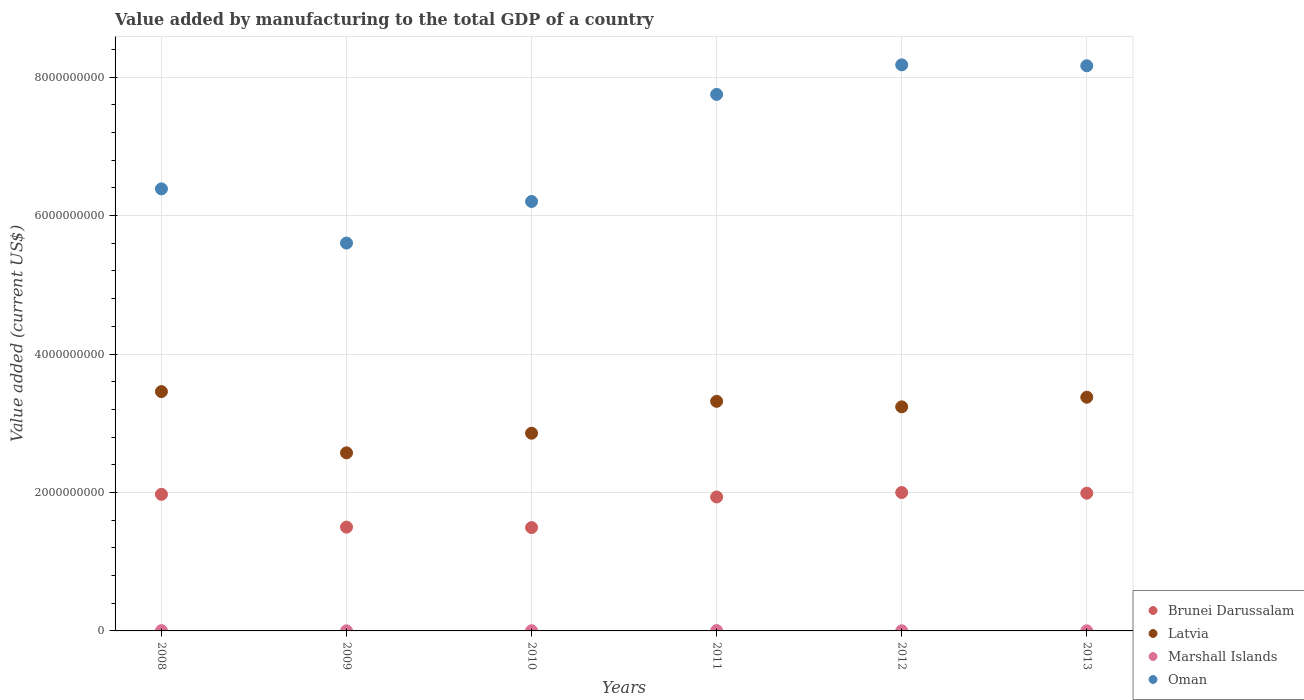How many different coloured dotlines are there?
Provide a short and direct response. 4. Is the number of dotlines equal to the number of legend labels?
Offer a terse response. Yes. What is the value added by manufacturing to the total GDP in Brunei Darussalam in 2011?
Give a very brief answer. 1.93e+09. Across all years, what is the maximum value added by manufacturing to the total GDP in Oman?
Offer a very short reply. 8.18e+09. Across all years, what is the minimum value added by manufacturing to the total GDP in Brunei Darussalam?
Offer a terse response. 1.49e+09. In which year was the value added by manufacturing to the total GDP in Brunei Darussalam maximum?
Make the answer very short. 2012. What is the total value added by manufacturing to the total GDP in Oman in the graph?
Offer a very short reply. 4.23e+1. What is the difference between the value added by manufacturing to the total GDP in Oman in 2011 and that in 2012?
Offer a very short reply. -4.27e+08. What is the difference between the value added by manufacturing to the total GDP in Marshall Islands in 2013 and the value added by manufacturing to the total GDP in Oman in 2012?
Your answer should be very brief. -8.18e+09. What is the average value added by manufacturing to the total GDP in Latvia per year?
Give a very brief answer. 3.14e+09. In the year 2012, what is the difference between the value added by manufacturing to the total GDP in Oman and value added by manufacturing to the total GDP in Brunei Darussalam?
Offer a very short reply. 6.18e+09. What is the ratio of the value added by manufacturing to the total GDP in Brunei Darussalam in 2010 to that in 2013?
Give a very brief answer. 0.75. Is the value added by manufacturing to the total GDP in Oman in 2008 less than that in 2009?
Make the answer very short. No. Is the difference between the value added by manufacturing to the total GDP in Oman in 2008 and 2013 greater than the difference between the value added by manufacturing to the total GDP in Brunei Darussalam in 2008 and 2013?
Provide a short and direct response. No. What is the difference between the highest and the second highest value added by manufacturing to the total GDP in Oman?
Offer a very short reply. 1.30e+07. What is the difference between the highest and the lowest value added by manufacturing to the total GDP in Brunei Darussalam?
Your response must be concise. 5.06e+08. Is it the case that in every year, the sum of the value added by manufacturing to the total GDP in Brunei Darussalam and value added by manufacturing to the total GDP in Marshall Islands  is greater than the value added by manufacturing to the total GDP in Oman?
Provide a short and direct response. No. Is the value added by manufacturing to the total GDP in Oman strictly greater than the value added by manufacturing to the total GDP in Latvia over the years?
Your response must be concise. Yes. Is the value added by manufacturing to the total GDP in Brunei Darussalam strictly less than the value added by manufacturing to the total GDP in Marshall Islands over the years?
Your response must be concise. No. How many years are there in the graph?
Give a very brief answer. 6. What is the difference between two consecutive major ticks on the Y-axis?
Your response must be concise. 2.00e+09. How many legend labels are there?
Provide a succinct answer. 4. What is the title of the graph?
Provide a short and direct response. Value added by manufacturing to the total GDP of a country. Does "Zimbabwe" appear as one of the legend labels in the graph?
Your answer should be compact. No. What is the label or title of the Y-axis?
Provide a succinct answer. Value added (current US$). What is the Value added (current US$) of Brunei Darussalam in 2008?
Ensure brevity in your answer.  1.97e+09. What is the Value added (current US$) in Latvia in 2008?
Offer a terse response. 3.46e+09. What is the Value added (current US$) in Marshall Islands in 2008?
Offer a terse response. 4.20e+06. What is the Value added (current US$) of Oman in 2008?
Your answer should be very brief. 6.39e+09. What is the Value added (current US$) of Brunei Darussalam in 2009?
Ensure brevity in your answer.  1.50e+09. What is the Value added (current US$) of Latvia in 2009?
Provide a succinct answer. 2.57e+09. What is the Value added (current US$) in Marshall Islands in 2009?
Offer a very short reply. 1.06e+06. What is the Value added (current US$) of Oman in 2009?
Give a very brief answer. 5.60e+09. What is the Value added (current US$) in Brunei Darussalam in 2010?
Offer a terse response. 1.49e+09. What is the Value added (current US$) in Latvia in 2010?
Make the answer very short. 2.86e+09. What is the Value added (current US$) of Marshall Islands in 2010?
Your answer should be very brief. 2.80e+06. What is the Value added (current US$) in Oman in 2010?
Your answer should be very brief. 6.20e+09. What is the Value added (current US$) of Brunei Darussalam in 2011?
Provide a succinct answer. 1.93e+09. What is the Value added (current US$) of Latvia in 2011?
Keep it short and to the point. 3.32e+09. What is the Value added (current US$) in Marshall Islands in 2011?
Your response must be concise. 4.95e+06. What is the Value added (current US$) of Oman in 2011?
Ensure brevity in your answer.  7.75e+09. What is the Value added (current US$) of Brunei Darussalam in 2012?
Make the answer very short. 2.00e+09. What is the Value added (current US$) in Latvia in 2012?
Provide a short and direct response. 3.24e+09. What is the Value added (current US$) of Marshall Islands in 2012?
Your answer should be very brief. 1.80e+06. What is the Value added (current US$) in Oman in 2012?
Ensure brevity in your answer.  8.18e+09. What is the Value added (current US$) of Brunei Darussalam in 2013?
Provide a short and direct response. 1.99e+09. What is the Value added (current US$) of Latvia in 2013?
Ensure brevity in your answer.  3.38e+09. What is the Value added (current US$) in Marshall Islands in 2013?
Your answer should be very brief. 1.32e+06. What is the Value added (current US$) in Oman in 2013?
Offer a very short reply. 8.16e+09. Across all years, what is the maximum Value added (current US$) in Brunei Darussalam?
Provide a succinct answer. 2.00e+09. Across all years, what is the maximum Value added (current US$) in Latvia?
Give a very brief answer. 3.46e+09. Across all years, what is the maximum Value added (current US$) of Marshall Islands?
Your response must be concise. 4.95e+06. Across all years, what is the maximum Value added (current US$) of Oman?
Your answer should be very brief. 8.18e+09. Across all years, what is the minimum Value added (current US$) in Brunei Darussalam?
Keep it short and to the point. 1.49e+09. Across all years, what is the minimum Value added (current US$) of Latvia?
Offer a very short reply. 2.57e+09. Across all years, what is the minimum Value added (current US$) of Marshall Islands?
Ensure brevity in your answer.  1.06e+06. Across all years, what is the minimum Value added (current US$) in Oman?
Keep it short and to the point. 5.60e+09. What is the total Value added (current US$) in Brunei Darussalam in the graph?
Provide a short and direct response. 1.09e+1. What is the total Value added (current US$) of Latvia in the graph?
Ensure brevity in your answer.  1.88e+1. What is the total Value added (current US$) in Marshall Islands in the graph?
Your answer should be very brief. 1.61e+07. What is the total Value added (current US$) in Oman in the graph?
Keep it short and to the point. 4.23e+1. What is the difference between the Value added (current US$) in Brunei Darussalam in 2008 and that in 2009?
Keep it short and to the point. 4.74e+08. What is the difference between the Value added (current US$) of Latvia in 2008 and that in 2009?
Ensure brevity in your answer.  8.85e+08. What is the difference between the Value added (current US$) in Marshall Islands in 2008 and that in 2009?
Give a very brief answer. 3.13e+06. What is the difference between the Value added (current US$) of Oman in 2008 and that in 2009?
Your response must be concise. 7.83e+08. What is the difference between the Value added (current US$) of Brunei Darussalam in 2008 and that in 2010?
Ensure brevity in your answer.  4.80e+08. What is the difference between the Value added (current US$) in Latvia in 2008 and that in 2010?
Offer a terse response. 6.01e+08. What is the difference between the Value added (current US$) in Marshall Islands in 2008 and that in 2010?
Keep it short and to the point. 1.40e+06. What is the difference between the Value added (current US$) of Oman in 2008 and that in 2010?
Keep it short and to the point. 1.82e+08. What is the difference between the Value added (current US$) of Brunei Darussalam in 2008 and that in 2011?
Give a very brief answer. 3.81e+07. What is the difference between the Value added (current US$) of Latvia in 2008 and that in 2011?
Your answer should be very brief. 1.41e+08. What is the difference between the Value added (current US$) of Marshall Islands in 2008 and that in 2011?
Provide a short and direct response. -7.55e+05. What is the difference between the Value added (current US$) of Oman in 2008 and that in 2011?
Your answer should be very brief. -1.36e+09. What is the difference between the Value added (current US$) in Brunei Darussalam in 2008 and that in 2012?
Your response must be concise. -2.64e+07. What is the difference between the Value added (current US$) of Latvia in 2008 and that in 2012?
Your response must be concise. 2.20e+08. What is the difference between the Value added (current US$) of Marshall Islands in 2008 and that in 2012?
Your answer should be very brief. 2.40e+06. What is the difference between the Value added (current US$) of Oman in 2008 and that in 2012?
Your answer should be compact. -1.79e+09. What is the difference between the Value added (current US$) in Brunei Darussalam in 2008 and that in 2013?
Offer a terse response. -1.66e+07. What is the difference between the Value added (current US$) in Latvia in 2008 and that in 2013?
Offer a terse response. 8.13e+07. What is the difference between the Value added (current US$) of Marshall Islands in 2008 and that in 2013?
Offer a very short reply. 2.88e+06. What is the difference between the Value added (current US$) in Oman in 2008 and that in 2013?
Offer a terse response. -1.78e+09. What is the difference between the Value added (current US$) of Brunei Darussalam in 2009 and that in 2010?
Provide a succinct answer. 6.36e+06. What is the difference between the Value added (current US$) in Latvia in 2009 and that in 2010?
Make the answer very short. -2.83e+08. What is the difference between the Value added (current US$) of Marshall Islands in 2009 and that in 2010?
Offer a terse response. -1.73e+06. What is the difference between the Value added (current US$) of Oman in 2009 and that in 2010?
Offer a terse response. -6.01e+08. What is the difference between the Value added (current US$) in Brunei Darussalam in 2009 and that in 2011?
Make the answer very short. -4.36e+08. What is the difference between the Value added (current US$) of Latvia in 2009 and that in 2011?
Provide a short and direct response. -7.44e+08. What is the difference between the Value added (current US$) of Marshall Islands in 2009 and that in 2011?
Provide a short and direct response. -3.89e+06. What is the difference between the Value added (current US$) in Oman in 2009 and that in 2011?
Provide a succinct answer. -2.15e+09. What is the difference between the Value added (current US$) of Brunei Darussalam in 2009 and that in 2012?
Make the answer very short. -5.00e+08. What is the difference between the Value added (current US$) in Latvia in 2009 and that in 2012?
Your answer should be very brief. -6.64e+08. What is the difference between the Value added (current US$) of Marshall Islands in 2009 and that in 2012?
Offer a terse response. -7.34e+05. What is the difference between the Value added (current US$) in Oman in 2009 and that in 2012?
Ensure brevity in your answer.  -2.57e+09. What is the difference between the Value added (current US$) of Brunei Darussalam in 2009 and that in 2013?
Your response must be concise. -4.90e+08. What is the difference between the Value added (current US$) in Latvia in 2009 and that in 2013?
Your answer should be compact. -8.03e+08. What is the difference between the Value added (current US$) of Marshall Islands in 2009 and that in 2013?
Your answer should be compact. -2.54e+05. What is the difference between the Value added (current US$) of Oman in 2009 and that in 2013?
Your answer should be very brief. -2.56e+09. What is the difference between the Value added (current US$) in Brunei Darussalam in 2010 and that in 2011?
Offer a terse response. -4.42e+08. What is the difference between the Value added (current US$) in Latvia in 2010 and that in 2011?
Offer a terse response. -4.61e+08. What is the difference between the Value added (current US$) of Marshall Islands in 2010 and that in 2011?
Your response must be concise. -2.16e+06. What is the difference between the Value added (current US$) in Oman in 2010 and that in 2011?
Give a very brief answer. -1.55e+09. What is the difference between the Value added (current US$) of Brunei Darussalam in 2010 and that in 2012?
Offer a terse response. -5.06e+08. What is the difference between the Value added (current US$) in Latvia in 2010 and that in 2012?
Your answer should be very brief. -3.81e+08. What is the difference between the Value added (current US$) in Marshall Islands in 2010 and that in 2012?
Offer a terse response. 9.96e+05. What is the difference between the Value added (current US$) in Oman in 2010 and that in 2012?
Keep it short and to the point. -1.97e+09. What is the difference between the Value added (current US$) of Brunei Darussalam in 2010 and that in 2013?
Your answer should be compact. -4.97e+08. What is the difference between the Value added (current US$) of Latvia in 2010 and that in 2013?
Make the answer very short. -5.20e+08. What is the difference between the Value added (current US$) in Marshall Islands in 2010 and that in 2013?
Keep it short and to the point. 1.48e+06. What is the difference between the Value added (current US$) in Oman in 2010 and that in 2013?
Keep it short and to the point. -1.96e+09. What is the difference between the Value added (current US$) of Brunei Darussalam in 2011 and that in 2012?
Make the answer very short. -6.45e+07. What is the difference between the Value added (current US$) of Latvia in 2011 and that in 2012?
Make the answer very short. 7.97e+07. What is the difference between the Value added (current US$) in Marshall Islands in 2011 and that in 2012?
Offer a very short reply. 3.15e+06. What is the difference between the Value added (current US$) in Oman in 2011 and that in 2012?
Offer a terse response. -4.27e+08. What is the difference between the Value added (current US$) in Brunei Darussalam in 2011 and that in 2013?
Provide a succinct answer. -5.46e+07. What is the difference between the Value added (current US$) of Latvia in 2011 and that in 2013?
Ensure brevity in your answer.  -5.94e+07. What is the difference between the Value added (current US$) in Marshall Islands in 2011 and that in 2013?
Your response must be concise. 3.63e+06. What is the difference between the Value added (current US$) in Oman in 2011 and that in 2013?
Ensure brevity in your answer.  -4.14e+08. What is the difference between the Value added (current US$) in Brunei Darussalam in 2012 and that in 2013?
Provide a succinct answer. 9.83e+06. What is the difference between the Value added (current US$) in Latvia in 2012 and that in 2013?
Keep it short and to the point. -1.39e+08. What is the difference between the Value added (current US$) in Marshall Islands in 2012 and that in 2013?
Make the answer very short. 4.81e+05. What is the difference between the Value added (current US$) of Oman in 2012 and that in 2013?
Provide a succinct answer. 1.30e+07. What is the difference between the Value added (current US$) in Brunei Darussalam in 2008 and the Value added (current US$) in Latvia in 2009?
Offer a terse response. -6.00e+08. What is the difference between the Value added (current US$) in Brunei Darussalam in 2008 and the Value added (current US$) in Marshall Islands in 2009?
Provide a short and direct response. 1.97e+09. What is the difference between the Value added (current US$) in Brunei Darussalam in 2008 and the Value added (current US$) in Oman in 2009?
Provide a short and direct response. -3.63e+09. What is the difference between the Value added (current US$) in Latvia in 2008 and the Value added (current US$) in Marshall Islands in 2009?
Make the answer very short. 3.46e+09. What is the difference between the Value added (current US$) of Latvia in 2008 and the Value added (current US$) of Oman in 2009?
Provide a short and direct response. -2.15e+09. What is the difference between the Value added (current US$) of Marshall Islands in 2008 and the Value added (current US$) of Oman in 2009?
Your answer should be compact. -5.60e+09. What is the difference between the Value added (current US$) of Brunei Darussalam in 2008 and the Value added (current US$) of Latvia in 2010?
Provide a short and direct response. -8.83e+08. What is the difference between the Value added (current US$) of Brunei Darussalam in 2008 and the Value added (current US$) of Marshall Islands in 2010?
Give a very brief answer. 1.97e+09. What is the difference between the Value added (current US$) of Brunei Darussalam in 2008 and the Value added (current US$) of Oman in 2010?
Offer a terse response. -4.23e+09. What is the difference between the Value added (current US$) of Latvia in 2008 and the Value added (current US$) of Marshall Islands in 2010?
Keep it short and to the point. 3.45e+09. What is the difference between the Value added (current US$) of Latvia in 2008 and the Value added (current US$) of Oman in 2010?
Your answer should be compact. -2.75e+09. What is the difference between the Value added (current US$) of Marshall Islands in 2008 and the Value added (current US$) of Oman in 2010?
Your answer should be very brief. -6.20e+09. What is the difference between the Value added (current US$) of Brunei Darussalam in 2008 and the Value added (current US$) of Latvia in 2011?
Keep it short and to the point. -1.34e+09. What is the difference between the Value added (current US$) of Brunei Darussalam in 2008 and the Value added (current US$) of Marshall Islands in 2011?
Offer a terse response. 1.97e+09. What is the difference between the Value added (current US$) in Brunei Darussalam in 2008 and the Value added (current US$) in Oman in 2011?
Offer a very short reply. -5.78e+09. What is the difference between the Value added (current US$) in Latvia in 2008 and the Value added (current US$) in Marshall Islands in 2011?
Keep it short and to the point. 3.45e+09. What is the difference between the Value added (current US$) of Latvia in 2008 and the Value added (current US$) of Oman in 2011?
Give a very brief answer. -4.29e+09. What is the difference between the Value added (current US$) in Marshall Islands in 2008 and the Value added (current US$) in Oman in 2011?
Offer a very short reply. -7.75e+09. What is the difference between the Value added (current US$) in Brunei Darussalam in 2008 and the Value added (current US$) in Latvia in 2012?
Provide a short and direct response. -1.26e+09. What is the difference between the Value added (current US$) in Brunei Darussalam in 2008 and the Value added (current US$) in Marshall Islands in 2012?
Your answer should be compact. 1.97e+09. What is the difference between the Value added (current US$) in Brunei Darussalam in 2008 and the Value added (current US$) in Oman in 2012?
Your answer should be compact. -6.20e+09. What is the difference between the Value added (current US$) in Latvia in 2008 and the Value added (current US$) in Marshall Islands in 2012?
Offer a very short reply. 3.46e+09. What is the difference between the Value added (current US$) of Latvia in 2008 and the Value added (current US$) of Oman in 2012?
Keep it short and to the point. -4.72e+09. What is the difference between the Value added (current US$) of Marshall Islands in 2008 and the Value added (current US$) of Oman in 2012?
Provide a succinct answer. -8.17e+09. What is the difference between the Value added (current US$) in Brunei Darussalam in 2008 and the Value added (current US$) in Latvia in 2013?
Provide a succinct answer. -1.40e+09. What is the difference between the Value added (current US$) of Brunei Darussalam in 2008 and the Value added (current US$) of Marshall Islands in 2013?
Give a very brief answer. 1.97e+09. What is the difference between the Value added (current US$) of Brunei Darussalam in 2008 and the Value added (current US$) of Oman in 2013?
Keep it short and to the point. -6.19e+09. What is the difference between the Value added (current US$) of Latvia in 2008 and the Value added (current US$) of Marshall Islands in 2013?
Keep it short and to the point. 3.46e+09. What is the difference between the Value added (current US$) of Latvia in 2008 and the Value added (current US$) of Oman in 2013?
Your answer should be compact. -4.71e+09. What is the difference between the Value added (current US$) in Marshall Islands in 2008 and the Value added (current US$) in Oman in 2013?
Give a very brief answer. -8.16e+09. What is the difference between the Value added (current US$) of Brunei Darussalam in 2009 and the Value added (current US$) of Latvia in 2010?
Give a very brief answer. -1.36e+09. What is the difference between the Value added (current US$) of Brunei Darussalam in 2009 and the Value added (current US$) of Marshall Islands in 2010?
Make the answer very short. 1.50e+09. What is the difference between the Value added (current US$) of Brunei Darussalam in 2009 and the Value added (current US$) of Oman in 2010?
Your response must be concise. -4.70e+09. What is the difference between the Value added (current US$) in Latvia in 2009 and the Value added (current US$) in Marshall Islands in 2010?
Offer a very short reply. 2.57e+09. What is the difference between the Value added (current US$) of Latvia in 2009 and the Value added (current US$) of Oman in 2010?
Your answer should be compact. -3.63e+09. What is the difference between the Value added (current US$) of Marshall Islands in 2009 and the Value added (current US$) of Oman in 2010?
Your response must be concise. -6.20e+09. What is the difference between the Value added (current US$) of Brunei Darussalam in 2009 and the Value added (current US$) of Latvia in 2011?
Provide a short and direct response. -1.82e+09. What is the difference between the Value added (current US$) of Brunei Darussalam in 2009 and the Value added (current US$) of Marshall Islands in 2011?
Your answer should be very brief. 1.49e+09. What is the difference between the Value added (current US$) of Brunei Darussalam in 2009 and the Value added (current US$) of Oman in 2011?
Your answer should be compact. -6.25e+09. What is the difference between the Value added (current US$) of Latvia in 2009 and the Value added (current US$) of Marshall Islands in 2011?
Give a very brief answer. 2.57e+09. What is the difference between the Value added (current US$) of Latvia in 2009 and the Value added (current US$) of Oman in 2011?
Your answer should be compact. -5.18e+09. What is the difference between the Value added (current US$) in Marshall Islands in 2009 and the Value added (current US$) in Oman in 2011?
Provide a short and direct response. -7.75e+09. What is the difference between the Value added (current US$) in Brunei Darussalam in 2009 and the Value added (current US$) in Latvia in 2012?
Your response must be concise. -1.74e+09. What is the difference between the Value added (current US$) of Brunei Darussalam in 2009 and the Value added (current US$) of Marshall Islands in 2012?
Your response must be concise. 1.50e+09. What is the difference between the Value added (current US$) of Brunei Darussalam in 2009 and the Value added (current US$) of Oman in 2012?
Keep it short and to the point. -6.68e+09. What is the difference between the Value added (current US$) of Latvia in 2009 and the Value added (current US$) of Marshall Islands in 2012?
Your response must be concise. 2.57e+09. What is the difference between the Value added (current US$) of Latvia in 2009 and the Value added (current US$) of Oman in 2012?
Provide a succinct answer. -5.60e+09. What is the difference between the Value added (current US$) in Marshall Islands in 2009 and the Value added (current US$) in Oman in 2012?
Your response must be concise. -8.18e+09. What is the difference between the Value added (current US$) of Brunei Darussalam in 2009 and the Value added (current US$) of Latvia in 2013?
Make the answer very short. -1.88e+09. What is the difference between the Value added (current US$) of Brunei Darussalam in 2009 and the Value added (current US$) of Marshall Islands in 2013?
Your answer should be compact. 1.50e+09. What is the difference between the Value added (current US$) of Brunei Darussalam in 2009 and the Value added (current US$) of Oman in 2013?
Your answer should be very brief. -6.66e+09. What is the difference between the Value added (current US$) in Latvia in 2009 and the Value added (current US$) in Marshall Islands in 2013?
Give a very brief answer. 2.57e+09. What is the difference between the Value added (current US$) of Latvia in 2009 and the Value added (current US$) of Oman in 2013?
Your response must be concise. -5.59e+09. What is the difference between the Value added (current US$) of Marshall Islands in 2009 and the Value added (current US$) of Oman in 2013?
Your answer should be compact. -8.16e+09. What is the difference between the Value added (current US$) in Brunei Darussalam in 2010 and the Value added (current US$) in Latvia in 2011?
Keep it short and to the point. -1.82e+09. What is the difference between the Value added (current US$) of Brunei Darussalam in 2010 and the Value added (current US$) of Marshall Islands in 2011?
Give a very brief answer. 1.49e+09. What is the difference between the Value added (current US$) in Brunei Darussalam in 2010 and the Value added (current US$) in Oman in 2011?
Provide a succinct answer. -6.26e+09. What is the difference between the Value added (current US$) of Latvia in 2010 and the Value added (current US$) of Marshall Islands in 2011?
Give a very brief answer. 2.85e+09. What is the difference between the Value added (current US$) in Latvia in 2010 and the Value added (current US$) in Oman in 2011?
Offer a terse response. -4.89e+09. What is the difference between the Value added (current US$) in Marshall Islands in 2010 and the Value added (current US$) in Oman in 2011?
Provide a short and direct response. -7.75e+09. What is the difference between the Value added (current US$) of Brunei Darussalam in 2010 and the Value added (current US$) of Latvia in 2012?
Keep it short and to the point. -1.74e+09. What is the difference between the Value added (current US$) of Brunei Darussalam in 2010 and the Value added (current US$) of Marshall Islands in 2012?
Keep it short and to the point. 1.49e+09. What is the difference between the Value added (current US$) in Brunei Darussalam in 2010 and the Value added (current US$) in Oman in 2012?
Your answer should be compact. -6.68e+09. What is the difference between the Value added (current US$) of Latvia in 2010 and the Value added (current US$) of Marshall Islands in 2012?
Provide a succinct answer. 2.85e+09. What is the difference between the Value added (current US$) in Latvia in 2010 and the Value added (current US$) in Oman in 2012?
Make the answer very short. -5.32e+09. What is the difference between the Value added (current US$) of Marshall Islands in 2010 and the Value added (current US$) of Oman in 2012?
Give a very brief answer. -8.17e+09. What is the difference between the Value added (current US$) of Brunei Darussalam in 2010 and the Value added (current US$) of Latvia in 2013?
Keep it short and to the point. -1.88e+09. What is the difference between the Value added (current US$) of Brunei Darussalam in 2010 and the Value added (current US$) of Marshall Islands in 2013?
Provide a short and direct response. 1.49e+09. What is the difference between the Value added (current US$) in Brunei Darussalam in 2010 and the Value added (current US$) in Oman in 2013?
Your answer should be very brief. -6.67e+09. What is the difference between the Value added (current US$) of Latvia in 2010 and the Value added (current US$) of Marshall Islands in 2013?
Offer a terse response. 2.85e+09. What is the difference between the Value added (current US$) of Latvia in 2010 and the Value added (current US$) of Oman in 2013?
Provide a short and direct response. -5.31e+09. What is the difference between the Value added (current US$) of Marshall Islands in 2010 and the Value added (current US$) of Oman in 2013?
Your answer should be very brief. -8.16e+09. What is the difference between the Value added (current US$) in Brunei Darussalam in 2011 and the Value added (current US$) in Latvia in 2012?
Your answer should be very brief. -1.30e+09. What is the difference between the Value added (current US$) of Brunei Darussalam in 2011 and the Value added (current US$) of Marshall Islands in 2012?
Give a very brief answer. 1.93e+09. What is the difference between the Value added (current US$) in Brunei Darussalam in 2011 and the Value added (current US$) in Oman in 2012?
Provide a short and direct response. -6.24e+09. What is the difference between the Value added (current US$) of Latvia in 2011 and the Value added (current US$) of Marshall Islands in 2012?
Give a very brief answer. 3.31e+09. What is the difference between the Value added (current US$) in Latvia in 2011 and the Value added (current US$) in Oman in 2012?
Your response must be concise. -4.86e+09. What is the difference between the Value added (current US$) in Marshall Islands in 2011 and the Value added (current US$) in Oman in 2012?
Make the answer very short. -8.17e+09. What is the difference between the Value added (current US$) of Brunei Darussalam in 2011 and the Value added (current US$) of Latvia in 2013?
Make the answer very short. -1.44e+09. What is the difference between the Value added (current US$) of Brunei Darussalam in 2011 and the Value added (current US$) of Marshall Islands in 2013?
Ensure brevity in your answer.  1.93e+09. What is the difference between the Value added (current US$) in Brunei Darussalam in 2011 and the Value added (current US$) in Oman in 2013?
Offer a very short reply. -6.23e+09. What is the difference between the Value added (current US$) in Latvia in 2011 and the Value added (current US$) in Marshall Islands in 2013?
Offer a very short reply. 3.32e+09. What is the difference between the Value added (current US$) in Latvia in 2011 and the Value added (current US$) in Oman in 2013?
Your answer should be very brief. -4.85e+09. What is the difference between the Value added (current US$) of Marshall Islands in 2011 and the Value added (current US$) of Oman in 2013?
Your answer should be compact. -8.16e+09. What is the difference between the Value added (current US$) of Brunei Darussalam in 2012 and the Value added (current US$) of Latvia in 2013?
Provide a succinct answer. -1.38e+09. What is the difference between the Value added (current US$) in Brunei Darussalam in 2012 and the Value added (current US$) in Marshall Islands in 2013?
Your answer should be very brief. 2.00e+09. What is the difference between the Value added (current US$) of Brunei Darussalam in 2012 and the Value added (current US$) of Oman in 2013?
Ensure brevity in your answer.  -6.16e+09. What is the difference between the Value added (current US$) of Latvia in 2012 and the Value added (current US$) of Marshall Islands in 2013?
Keep it short and to the point. 3.24e+09. What is the difference between the Value added (current US$) in Latvia in 2012 and the Value added (current US$) in Oman in 2013?
Your answer should be very brief. -4.93e+09. What is the difference between the Value added (current US$) of Marshall Islands in 2012 and the Value added (current US$) of Oman in 2013?
Offer a very short reply. -8.16e+09. What is the average Value added (current US$) in Brunei Darussalam per year?
Your answer should be very brief. 1.81e+09. What is the average Value added (current US$) in Latvia per year?
Your answer should be very brief. 3.14e+09. What is the average Value added (current US$) in Marshall Islands per year?
Provide a short and direct response. 2.69e+06. What is the average Value added (current US$) of Oman per year?
Give a very brief answer. 7.05e+09. In the year 2008, what is the difference between the Value added (current US$) in Brunei Darussalam and Value added (current US$) in Latvia?
Offer a very short reply. -1.48e+09. In the year 2008, what is the difference between the Value added (current US$) in Brunei Darussalam and Value added (current US$) in Marshall Islands?
Keep it short and to the point. 1.97e+09. In the year 2008, what is the difference between the Value added (current US$) in Brunei Darussalam and Value added (current US$) in Oman?
Provide a short and direct response. -4.41e+09. In the year 2008, what is the difference between the Value added (current US$) in Latvia and Value added (current US$) in Marshall Islands?
Your answer should be very brief. 3.45e+09. In the year 2008, what is the difference between the Value added (current US$) in Latvia and Value added (current US$) in Oman?
Provide a succinct answer. -2.93e+09. In the year 2008, what is the difference between the Value added (current US$) in Marshall Islands and Value added (current US$) in Oman?
Give a very brief answer. -6.38e+09. In the year 2009, what is the difference between the Value added (current US$) of Brunei Darussalam and Value added (current US$) of Latvia?
Ensure brevity in your answer.  -1.07e+09. In the year 2009, what is the difference between the Value added (current US$) of Brunei Darussalam and Value added (current US$) of Marshall Islands?
Your answer should be very brief. 1.50e+09. In the year 2009, what is the difference between the Value added (current US$) of Brunei Darussalam and Value added (current US$) of Oman?
Your answer should be compact. -4.10e+09. In the year 2009, what is the difference between the Value added (current US$) in Latvia and Value added (current US$) in Marshall Islands?
Ensure brevity in your answer.  2.57e+09. In the year 2009, what is the difference between the Value added (current US$) of Latvia and Value added (current US$) of Oman?
Offer a very short reply. -3.03e+09. In the year 2009, what is the difference between the Value added (current US$) in Marshall Islands and Value added (current US$) in Oman?
Give a very brief answer. -5.60e+09. In the year 2010, what is the difference between the Value added (current US$) in Brunei Darussalam and Value added (current US$) in Latvia?
Offer a very short reply. -1.36e+09. In the year 2010, what is the difference between the Value added (current US$) of Brunei Darussalam and Value added (current US$) of Marshall Islands?
Make the answer very short. 1.49e+09. In the year 2010, what is the difference between the Value added (current US$) of Brunei Darussalam and Value added (current US$) of Oman?
Provide a short and direct response. -4.71e+09. In the year 2010, what is the difference between the Value added (current US$) in Latvia and Value added (current US$) in Marshall Islands?
Your answer should be very brief. 2.85e+09. In the year 2010, what is the difference between the Value added (current US$) of Latvia and Value added (current US$) of Oman?
Offer a very short reply. -3.35e+09. In the year 2010, what is the difference between the Value added (current US$) in Marshall Islands and Value added (current US$) in Oman?
Your response must be concise. -6.20e+09. In the year 2011, what is the difference between the Value added (current US$) of Brunei Darussalam and Value added (current US$) of Latvia?
Provide a succinct answer. -1.38e+09. In the year 2011, what is the difference between the Value added (current US$) in Brunei Darussalam and Value added (current US$) in Marshall Islands?
Ensure brevity in your answer.  1.93e+09. In the year 2011, what is the difference between the Value added (current US$) of Brunei Darussalam and Value added (current US$) of Oman?
Provide a short and direct response. -5.82e+09. In the year 2011, what is the difference between the Value added (current US$) in Latvia and Value added (current US$) in Marshall Islands?
Offer a terse response. 3.31e+09. In the year 2011, what is the difference between the Value added (current US$) of Latvia and Value added (current US$) of Oman?
Provide a succinct answer. -4.43e+09. In the year 2011, what is the difference between the Value added (current US$) of Marshall Islands and Value added (current US$) of Oman?
Offer a terse response. -7.75e+09. In the year 2012, what is the difference between the Value added (current US$) in Brunei Darussalam and Value added (current US$) in Latvia?
Provide a succinct answer. -1.24e+09. In the year 2012, what is the difference between the Value added (current US$) in Brunei Darussalam and Value added (current US$) in Marshall Islands?
Offer a terse response. 2.00e+09. In the year 2012, what is the difference between the Value added (current US$) of Brunei Darussalam and Value added (current US$) of Oman?
Your response must be concise. -6.18e+09. In the year 2012, what is the difference between the Value added (current US$) in Latvia and Value added (current US$) in Marshall Islands?
Provide a short and direct response. 3.23e+09. In the year 2012, what is the difference between the Value added (current US$) in Latvia and Value added (current US$) in Oman?
Ensure brevity in your answer.  -4.94e+09. In the year 2012, what is the difference between the Value added (current US$) in Marshall Islands and Value added (current US$) in Oman?
Ensure brevity in your answer.  -8.18e+09. In the year 2013, what is the difference between the Value added (current US$) of Brunei Darussalam and Value added (current US$) of Latvia?
Provide a succinct answer. -1.39e+09. In the year 2013, what is the difference between the Value added (current US$) in Brunei Darussalam and Value added (current US$) in Marshall Islands?
Keep it short and to the point. 1.99e+09. In the year 2013, what is the difference between the Value added (current US$) of Brunei Darussalam and Value added (current US$) of Oman?
Keep it short and to the point. -6.17e+09. In the year 2013, what is the difference between the Value added (current US$) in Latvia and Value added (current US$) in Marshall Islands?
Ensure brevity in your answer.  3.37e+09. In the year 2013, what is the difference between the Value added (current US$) in Latvia and Value added (current US$) in Oman?
Provide a short and direct response. -4.79e+09. In the year 2013, what is the difference between the Value added (current US$) of Marshall Islands and Value added (current US$) of Oman?
Your response must be concise. -8.16e+09. What is the ratio of the Value added (current US$) in Brunei Darussalam in 2008 to that in 2009?
Your answer should be compact. 1.32. What is the ratio of the Value added (current US$) in Latvia in 2008 to that in 2009?
Make the answer very short. 1.34. What is the ratio of the Value added (current US$) in Marshall Islands in 2008 to that in 2009?
Give a very brief answer. 3.94. What is the ratio of the Value added (current US$) of Oman in 2008 to that in 2009?
Your response must be concise. 1.14. What is the ratio of the Value added (current US$) in Brunei Darussalam in 2008 to that in 2010?
Ensure brevity in your answer.  1.32. What is the ratio of the Value added (current US$) of Latvia in 2008 to that in 2010?
Your answer should be very brief. 1.21. What is the ratio of the Value added (current US$) of Marshall Islands in 2008 to that in 2010?
Provide a short and direct response. 1.5. What is the ratio of the Value added (current US$) of Oman in 2008 to that in 2010?
Your answer should be very brief. 1.03. What is the ratio of the Value added (current US$) of Brunei Darussalam in 2008 to that in 2011?
Offer a very short reply. 1.02. What is the ratio of the Value added (current US$) in Latvia in 2008 to that in 2011?
Make the answer very short. 1.04. What is the ratio of the Value added (current US$) of Marshall Islands in 2008 to that in 2011?
Make the answer very short. 0.85. What is the ratio of the Value added (current US$) in Oman in 2008 to that in 2011?
Provide a short and direct response. 0.82. What is the ratio of the Value added (current US$) of Brunei Darussalam in 2008 to that in 2012?
Your answer should be very brief. 0.99. What is the ratio of the Value added (current US$) of Latvia in 2008 to that in 2012?
Your answer should be very brief. 1.07. What is the ratio of the Value added (current US$) of Marshall Islands in 2008 to that in 2012?
Your answer should be compact. 2.33. What is the ratio of the Value added (current US$) of Oman in 2008 to that in 2012?
Ensure brevity in your answer.  0.78. What is the ratio of the Value added (current US$) of Latvia in 2008 to that in 2013?
Offer a terse response. 1.02. What is the ratio of the Value added (current US$) of Marshall Islands in 2008 to that in 2013?
Provide a short and direct response. 3.18. What is the ratio of the Value added (current US$) of Oman in 2008 to that in 2013?
Keep it short and to the point. 0.78. What is the ratio of the Value added (current US$) of Brunei Darussalam in 2009 to that in 2010?
Ensure brevity in your answer.  1. What is the ratio of the Value added (current US$) of Latvia in 2009 to that in 2010?
Offer a very short reply. 0.9. What is the ratio of the Value added (current US$) of Marshall Islands in 2009 to that in 2010?
Provide a short and direct response. 0.38. What is the ratio of the Value added (current US$) in Oman in 2009 to that in 2010?
Offer a terse response. 0.9. What is the ratio of the Value added (current US$) of Brunei Darussalam in 2009 to that in 2011?
Provide a short and direct response. 0.77. What is the ratio of the Value added (current US$) in Latvia in 2009 to that in 2011?
Offer a terse response. 0.78. What is the ratio of the Value added (current US$) of Marshall Islands in 2009 to that in 2011?
Your answer should be very brief. 0.21. What is the ratio of the Value added (current US$) of Oman in 2009 to that in 2011?
Make the answer very short. 0.72. What is the ratio of the Value added (current US$) in Brunei Darussalam in 2009 to that in 2012?
Give a very brief answer. 0.75. What is the ratio of the Value added (current US$) of Latvia in 2009 to that in 2012?
Offer a terse response. 0.79. What is the ratio of the Value added (current US$) in Marshall Islands in 2009 to that in 2012?
Give a very brief answer. 0.59. What is the ratio of the Value added (current US$) in Oman in 2009 to that in 2012?
Give a very brief answer. 0.69. What is the ratio of the Value added (current US$) in Brunei Darussalam in 2009 to that in 2013?
Provide a succinct answer. 0.75. What is the ratio of the Value added (current US$) of Latvia in 2009 to that in 2013?
Provide a succinct answer. 0.76. What is the ratio of the Value added (current US$) of Marshall Islands in 2009 to that in 2013?
Make the answer very short. 0.81. What is the ratio of the Value added (current US$) in Oman in 2009 to that in 2013?
Offer a very short reply. 0.69. What is the ratio of the Value added (current US$) in Brunei Darussalam in 2010 to that in 2011?
Offer a terse response. 0.77. What is the ratio of the Value added (current US$) of Latvia in 2010 to that in 2011?
Provide a succinct answer. 0.86. What is the ratio of the Value added (current US$) in Marshall Islands in 2010 to that in 2011?
Your answer should be very brief. 0.56. What is the ratio of the Value added (current US$) of Oman in 2010 to that in 2011?
Offer a very short reply. 0.8. What is the ratio of the Value added (current US$) in Brunei Darussalam in 2010 to that in 2012?
Provide a short and direct response. 0.75. What is the ratio of the Value added (current US$) in Latvia in 2010 to that in 2012?
Ensure brevity in your answer.  0.88. What is the ratio of the Value added (current US$) of Marshall Islands in 2010 to that in 2012?
Ensure brevity in your answer.  1.55. What is the ratio of the Value added (current US$) in Oman in 2010 to that in 2012?
Offer a very short reply. 0.76. What is the ratio of the Value added (current US$) of Brunei Darussalam in 2010 to that in 2013?
Offer a terse response. 0.75. What is the ratio of the Value added (current US$) of Latvia in 2010 to that in 2013?
Provide a short and direct response. 0.85. What is the ratio of the Value added (current US$) of Marshall Islands in 2010 to that in 2013?
Your answer should be compact. 2.12. What is the ratio of the Value added (current US$) of Oman in 2010 to that in 2013?
Keep it short and to the point. 0.76. What is the ratio of the Value added (current US$) of Brunei Darussalam in 2011 to that in 2012?
Provide a short and direct response. 0.97. What is the ratio of the Value added (current US$) of Latvia in 2011 to that in 2012?
Ensure brevity in your answer.  1.02. What is the ratio of the Value added (current US$) of Marshall Islands in 2011 to that in 2012?
Your answer should be very brief. 2.75. What is the ratio of the Value added (current US$) of Oman in 2011 to that in 2012?
Your answer should be compact. 0.95. What is the ratio of the Value added (current US$) of Brunei Darussalam in 2011 to that in 2013?
Provide a short and direct response. 0.97. What is the ratio of the Value added (current US$) of Latvia in 2011 to that in 2013?
Give a very brief answer. 0.98. What is the ratio of the Value added (current US$) in Marshall Islands in 2011 to that in 2013?
Keep it short and to the point. 3.76. What is the ratio of the Value added (current US$) of Oman in 2011 to that in 2013?
Provide a short and direct response. 0.95. What is the ratio of the Value added (current US$) in Latvia in 2012 to that in 2013?
Keep it short and to the point. 0.96. What is the ratio of the Value added (current US$) in Marshall Islands in 2012 to that in 2013?
Your answer should be compact. 1.36. What is the difference between the highest and the second highest Value added (current US$) of Brunei Darussalam?
Ensure brevity in your answer.  9.83e+06. What is the difference between the highest and the second highest Value added (current US$) in Latvia?
Provide a short and direct response. 8.13e+07. What is the difference between the highest and the second highest Value added (current US$) of Marshall Islands?
Your answer should be very brief. 7.55e+05. What is the difference between the highest and the second highest Value added (current US$) in Oman?
Your response must be concise. 1.30e+07. What is the difference between the highest and the lowest Value added (current US$) of Brunei Darussalam?
Make the answer very short. 5.06e+08. What is the difference between the highest and the lowest Value added (current US$) of Latvia?
Ensure brevity in your answer.  8.85e+08. What is the difference between the highest and the lowest Value added (current US$) of Marshall Islands?
Your response must be concise. 3.89e+06. What is the difference between the highest and the lowest Value added (current US$) in Oman?
Give a very brief answer. 2.57e+09. 